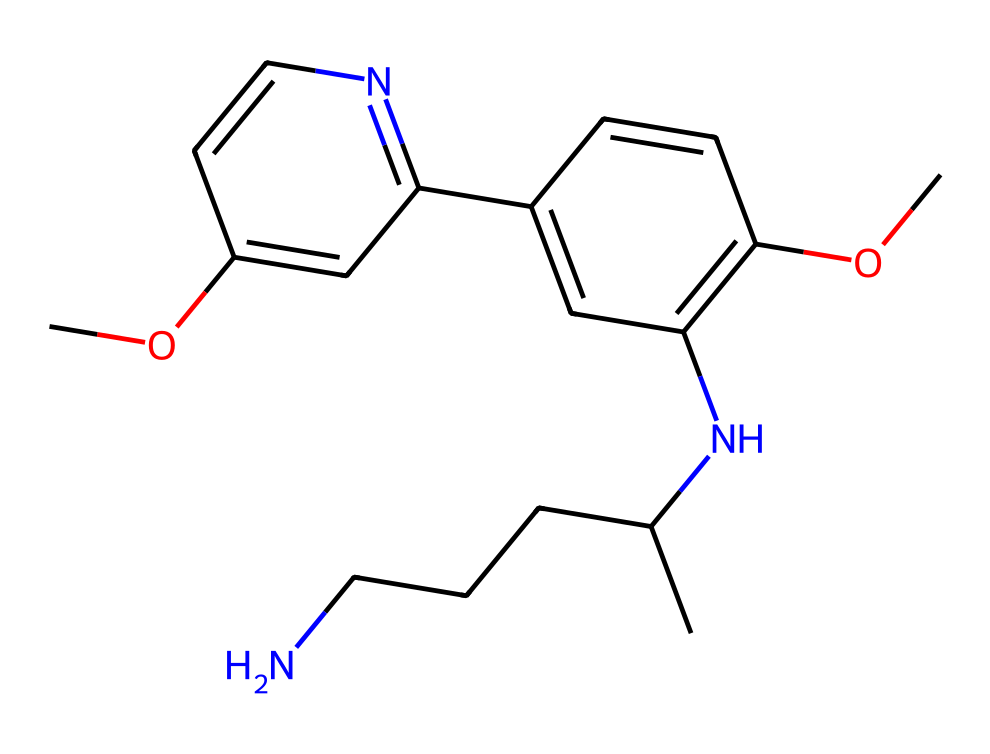What is the molecular formula of primaquine? To determine the molecular formula, count the number of each type of atom in the SMILES representation. The breakdown yields 15 carbon atoms (C), 20 hydrogen atoms (H), 2 nitrogen atoms (N), and 4 oxygen atoms (O), resulting in C15H20N2O4.
Answer: C15H20N2O4 How many rings are present in the structure of primaquine? By analyzing the SMILES representation, we can identify two distinct ring structures in the chemical, which involve the cyclic components indicated by "C1=" and "C2=". This leads us to conclude that there are two rings.
Answer: 2 What is the functional group present in primaquine? Observing the structure, we can identify the presence of methoxy (-OCH3) and amine (-NH-) functional groups in primaquine. These groups are marked by the specific attachments seen in the SMILES code.
Answer: methoxy and amine What type of compound is primaquine classified as? Primaquine can be classified as an antimalarial drug based on its function and its chemical structure, which features elements typically associated with pharmaceuticals aimed at treating malaria.
Answer: antimalarial What is the significance of the nitrogen atoms in primaquine's structure? The nitrogen atoms present in primaquine play a crucial role, as they are often associated with basicity and pharmacological activity, affecting the interaction of the drug with biological systems. This indicates a potential influence on its mechanism against malaria.
Answer: pharmacological activity Which part of primaquine contributes to its solubility? The presence of the methoxy group (-OCH3) in the chemical structure contributes significantly to the hydrophilicity of primaquine, enhancing its solubility in biological fluids.
Answer: methoxy group How many chiral centers does primaquine have? In the analysis of the structure, we can identify that primaquine has two chiral centers based on the presence of two carbon atoms bonded to four different substituents as represented in the SMILES notation.
Answer: 2 